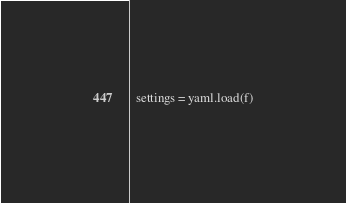<code> <loc_0><loc_0><loc_500><loc_500><_Python_>  settings = yaml.load(f)
</code> 